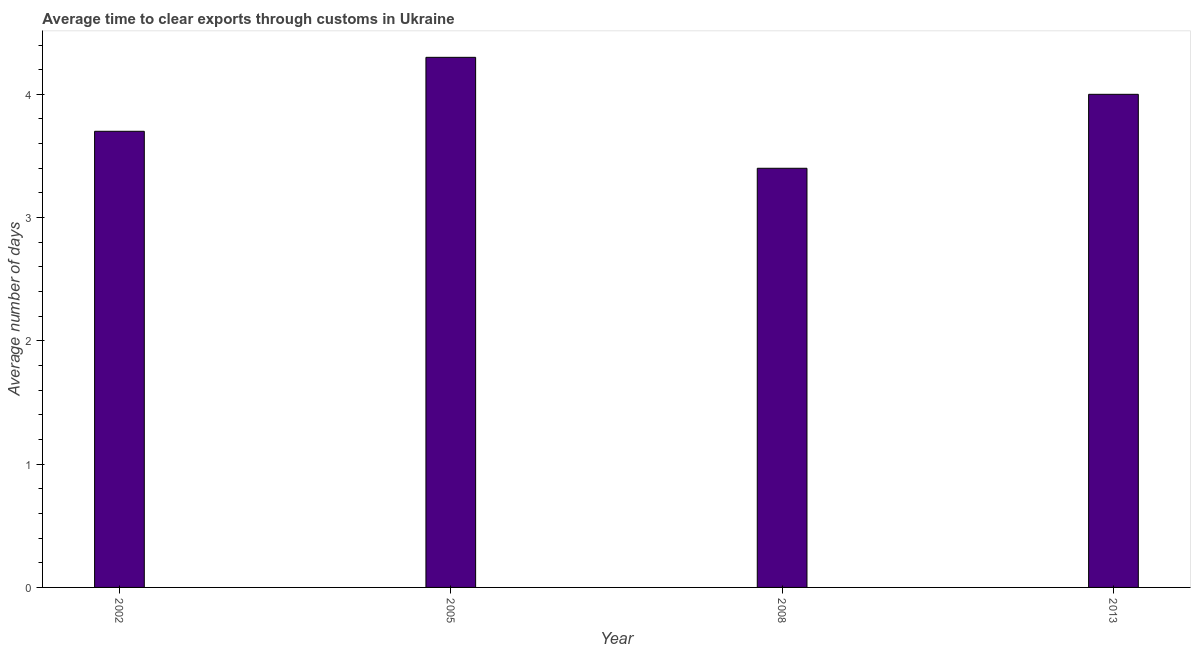Does the graph contain any zero values?
Keep it short and to the point. No. Does the graph contain grids?
Provide a succinct answer. No. What is the title of the graph?
Offer a terse response. Average time to clear exports through customs in Ukraine. What is the label or title of the Y-axis?
Keep it short and to the point. Average number of days. Across all years, what is the maximum time to clear exports through customs?
Your answer should be compact. 4.3. Across all years, what is the minimum time to clear exports through customs?
Make the answer very short. 3.4. What is the sum of the time to clear exports through customs?
Offer a very short reply. 15.4. What is the difference between the time to clear exports through customs in 2002 and 2005?
Ensure brevity in your answer.  -0.6. What is the average time to clear exports through customs per year?
Offer a terse response. 3.85. What is the median time to clear exports through customs?
Offer a terse response. 3.85. What is the ratio of the time to clear exports through customs in 2002 to that in 2013?
Give a very brief answer. 0.93. Is the time to clear exports through customs in 2008 less than that in 2013?
Your answer should be compact. Yes. What is the difference between the highest and the second highest time to clear exports through customs?
Ensure brevity in your answer.  0.3. Is the sum of the time to clear exports through customs in 2008 and 2013 greater than the maximum time to clear exports through customs across all years?
Give a very brief answer. Yes. Are all the bars in the graph horizontal?
Your answer should be compact. No. Are the values on the major ticks of Y-axis written in scientific E-notation?
Keep it short and to the point. No. What is the Average number of days in 2002?
Your answer should be compact. 3.7. What is the Average number of days of 2005?
Your answer should be compact. 4.3. What is the Average number of days of 2008?
Your answer should be very brief. 3.4. What is the Average number of days of 2013?
Give a very brief answer. 4. What is the difference between the Average number of days in 2002 and 2005?
Make the answer very short. -0.6. What is the difference between the Average number of days in 2005 and 2008?
Make the answer very short. 0.9. What is the difference between the Average number of days in 2005 and 2013?
Provide a short and direct response. 0.3. What is the ratio of the Average number of days in 2002 to that in 2005?
Provide a succinct answer. 0.86. What is the ratio of the Average number of days in 2002 to that in 2008?
Provide a short and direct response. 1.09. What is the ratio of the Average number of days in 2002 to that in 2013?
Your answer should be very brief. 0.93. What is the ratio of the Average number of days in 2005 to that in 2008?
Provide a succinct answer. 1.26. What is the ratio of the Average number of days in 2005 to that in 2013?
Provide a succinct answer. 1.07. What is the ratio of the Average number of days in 2008 to that in 2013?
Provide a short and direct response. 0.85. 